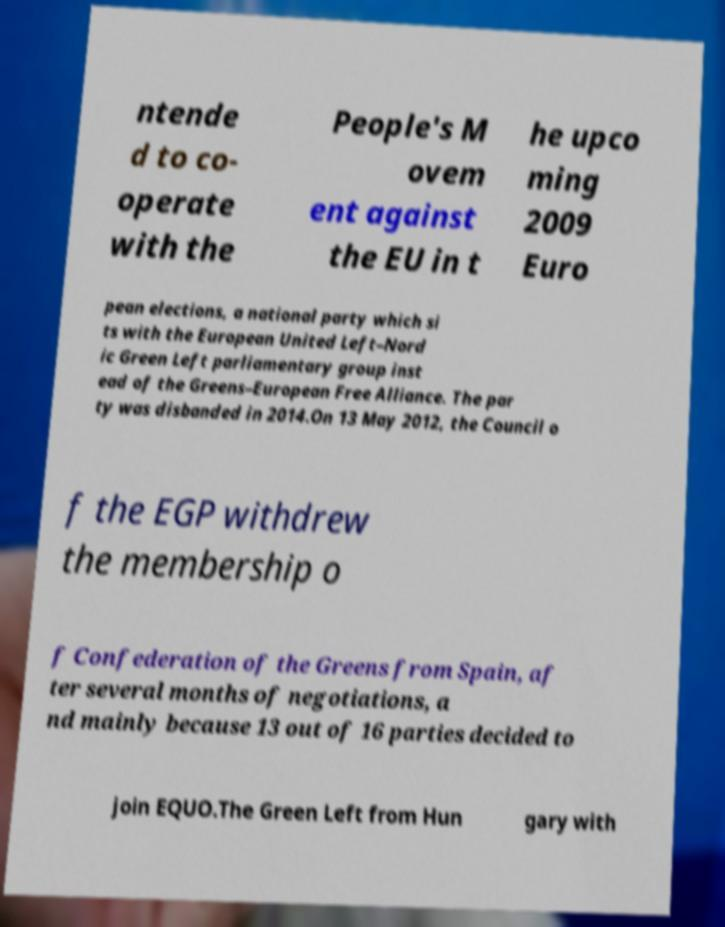Please read and relay the text visible in this image. What does it say? ntende d to co- operate with the People's M ovem ent against the EU in t he upco ming 2009 Euro pean elections, a national party which si ts with the European United Left–Nord ic Green Left parliamentary group inst ead of the Greens–European Free Alliance. The par ty was disbanded in 2014.On 13 May 2012, the Council o f the EGP withdrew the membership o f Confederation of the Greens from Spain, af ter several months of negotiations, a nd mainly because 13 out of 16 parties decided to join EQUO.The Green Left from Hun gary with 